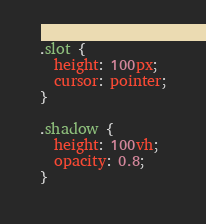<code> <loc_0><loc_0><loc_500><loc_500><_CSS_>.slot {
  height: 100px;
  cursor: pointer;
}

.shadow {
  height: 100vh;
  opacity: 0.8;
}
</code> 